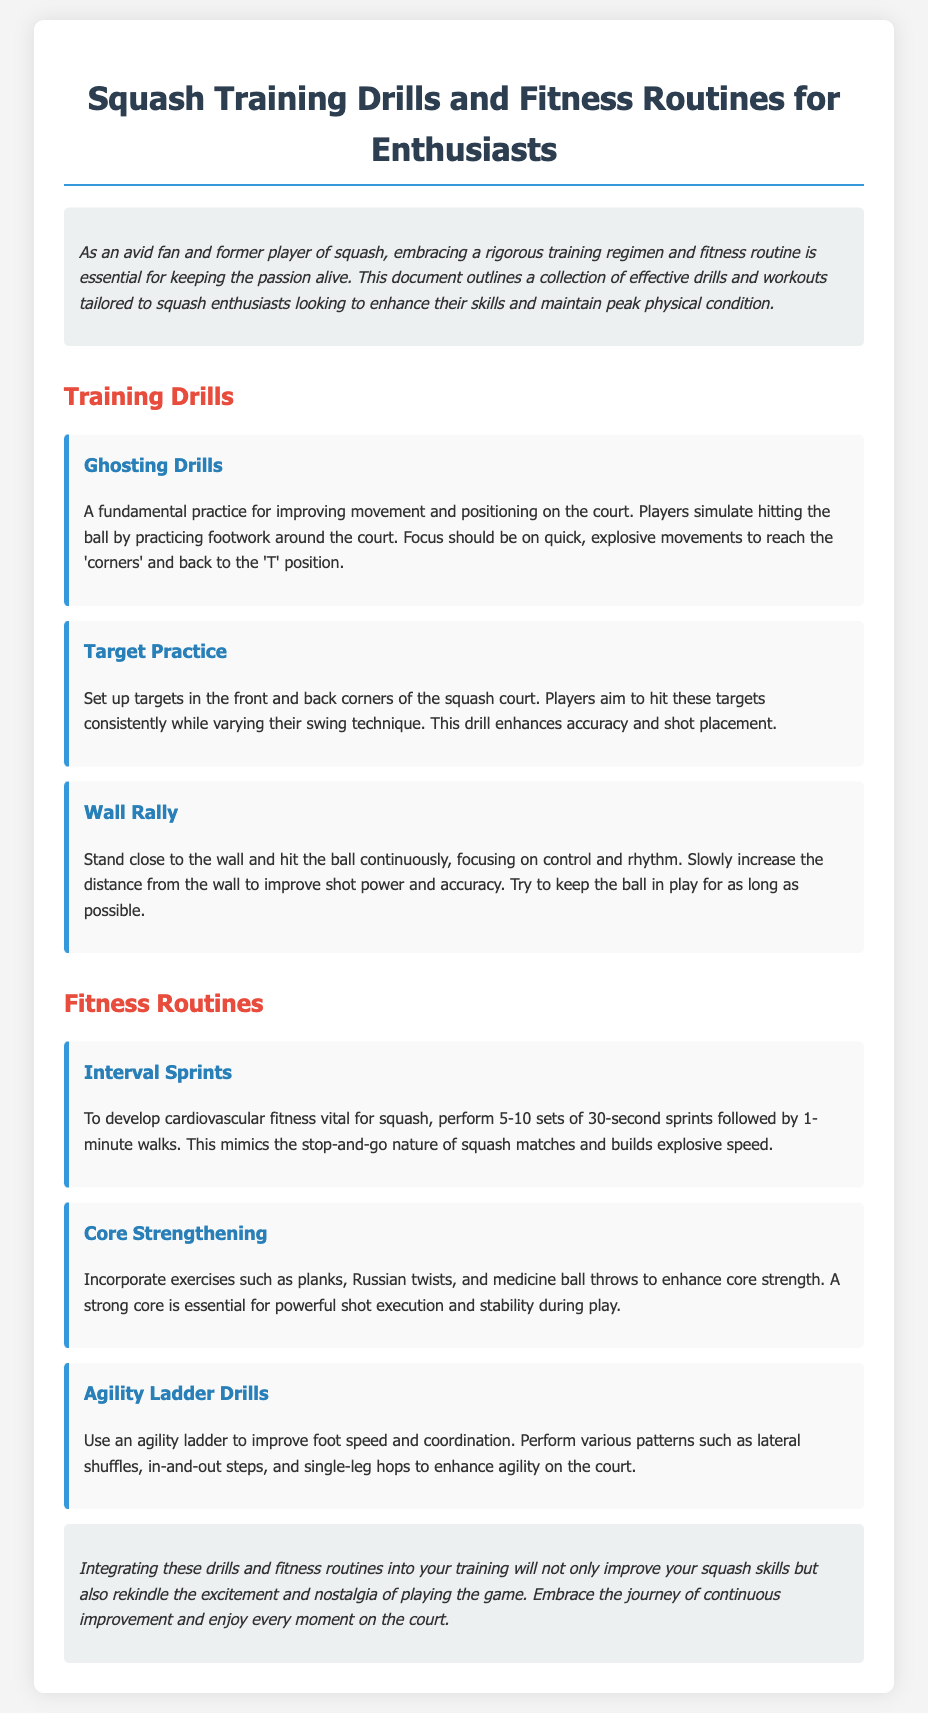What is the title of the document? The title can be found at the top of the document, introducing the main subject matter.
Answer: Squash Training Drills and Fitness Routines for Enthusiasts How many training drills are listed in the document? The drills are explicitly provided under the "Training Drills" section, and counting them gives the total.
Answer: 3 What type of exercise is emphasized for cardiovascular fitness? The document specifies a type of fitness routine aimed at improving cardiovascular health.
Answer: Interval Sprints What should players focus on during Ghosting Drills? The document describes what players need to concentrate on while performing this particular drill.
Answer: Quick, explosive movements What is a benefit of incorporating core strengthening exercises? The rationale for including core strengthening is clearly stated, highlighting its role in squash performance.
Answer: Powerful shot execution Which drill improves foot speed and coordination? The document identifies a specific drill that targets both foot speed and coordination.
Answer: Agility Ladder Drills How many sets of sprints are recommended in the fitness routine? The number of sets for interval sprints is detailed in the fitness routine section.
Answer: 5-10 What is the primary goal of Target Practice? The focus of this drill is mentioned, which indicates its purpose in training.
Answer: Enhances accuracy and shot placement 